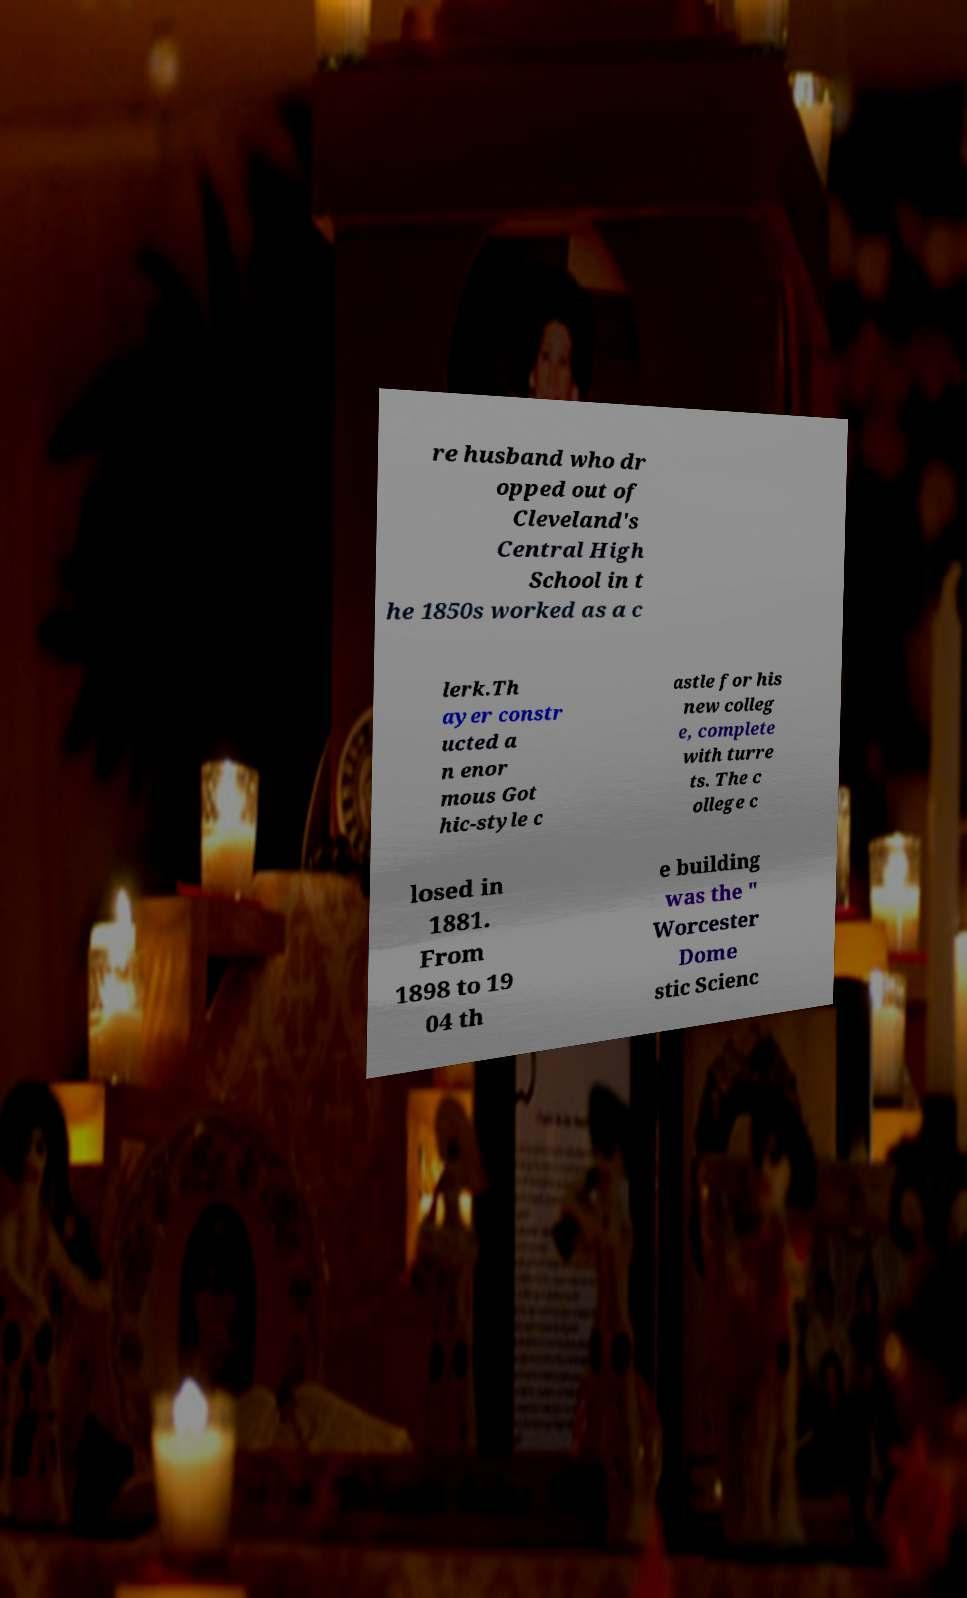Could you extract and type out the text from this image? re husband who dr opped out of Cleveland's Central High School in t he 1850s worked as a c lerk.Th ayer constr ucted a n enor mous Got hic-style c astle for his new colleg e, complete with turre ts. The c ollege c losed in 1881. From 1898 to 19 04 th e building was the " Worcester Dome stic Scienc 